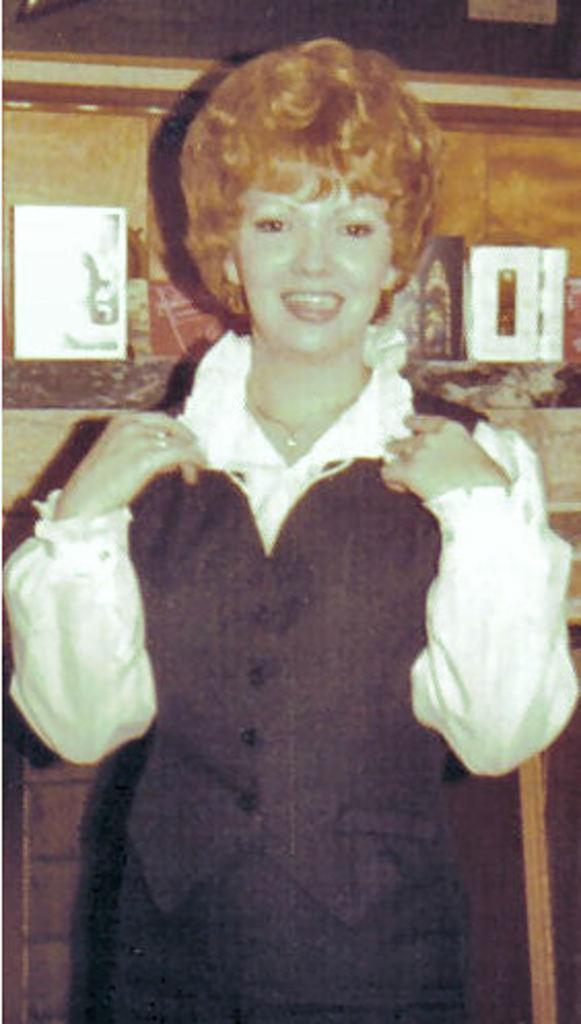Who is present in the image? There is a woman in the image. What is the woman doing in the image? The woman is standing and smiling. What can be seen in the background of the image? There is a photo in the image. What is inside the cupboard in the image? There are boxes in the cupboard. What type of design can be seen on the giant's clothing in the image? There are no giants present in the image, so it is not possible to determine the design on their clothing. 